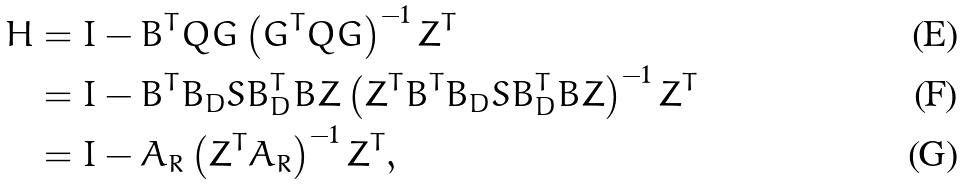Convert formula to latex. <formula><loc_0><loc_0><loc_500><loc_500>H & = I - B ^ { T } Q G \left ( G ^ { T } Q G \right ) ^ { - 1 } Z ^ { T } \\ & = I - B ^ { T } B _ { D } S B _ { D } ^ { T } B Z \left ( Z ^ { T } B ^ { T } B _ { D } S B _ { D } ^ { T } B Z \right ) ^ { - 1 } Z ^ { T } \\ & = I - A _ { R } \left ( Z ^ { T } A _ { R } \right ) ^ { - 1 } Z ^ { T } ,</formula> 